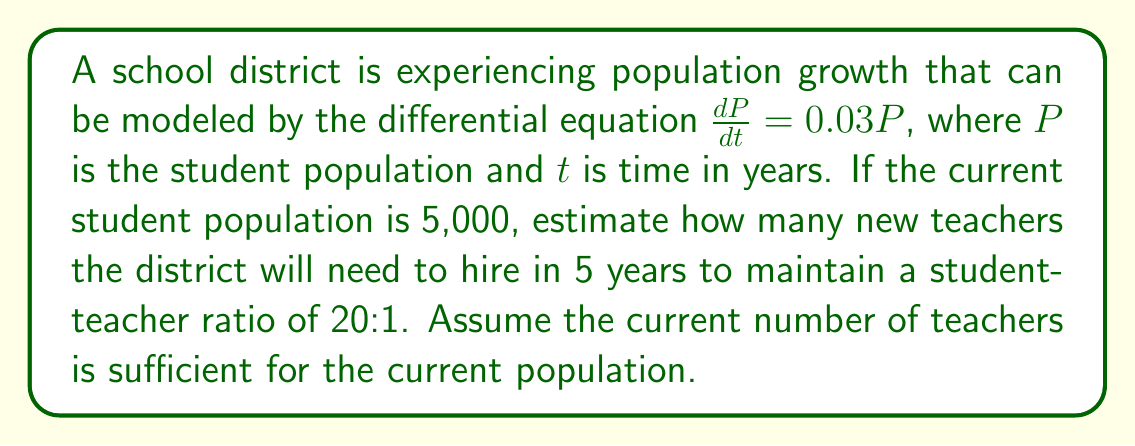Teach me how to tackle this problem. 1. The given differential equation is a model for exponential growth:
   $\frac{dP}{dt} = 0.03P$

2. The solution to this equation is:
   $P(t) = P_0e^{0.03t}$
   where $P_0$ is the initial population.

3. We're given that $P_0 = 5,000$ and we need to find $P(5)$:
   $P(5) = 5,000e^{0.03 * 5} = 5,000e^{0.15}$

4. Calculate this value:
   $P(5) = 5,000 * 1.1618 \approx 5,809$ students

5. To find the number of new teachers needed:
   a. Calculate total teachers needed at t=5:
      $5,809 / 20 \approx 290.45$, round up to 291 teachers
   b. Current teachers: $5,000 / 20 = 250$
   c. New teachers needed: $291 - 250 = 41$

Therefore, the district will need to hire approximately 41 new teachers in 5 years.
Answer: 41 new teachers 